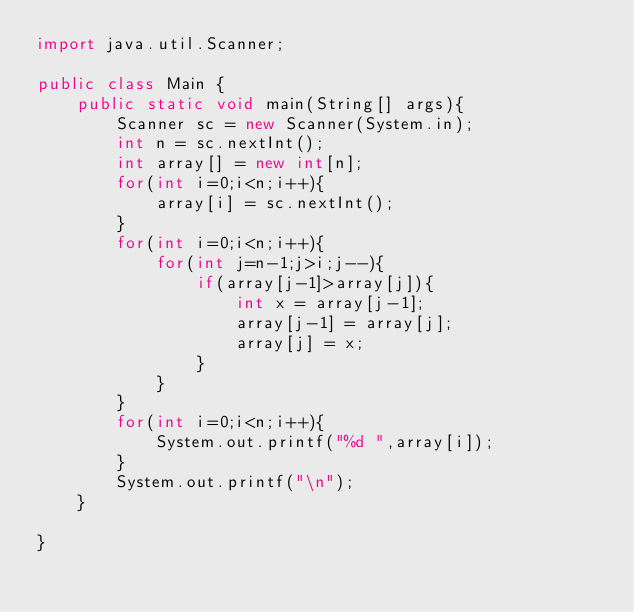Convert code to text. <code><loc_0><loc_0><loc_500><loc_500><_Java_>import java.util.Scanner;

public class Main {
	public static void main(String[] args){
		Scanner sc = new Scanner(System.in);
		int n = sc.nextInt();
		int array[] = new int[n];
		for(int i=0;i<n;i++){
			array[i] = sc.nextInt();
		}
		for(int i=0;i<n;i++){
			for(int j=n-1;j>i;j--){
				if(array[j-1]>array[j]){
					int x = array[j-1];
					array[j-1] = array[j];
					array[j] = x;
				}
			}
		}
		for(int i=0;i<n;i++){
			System.out.printf("%d ",array[i]);
		}
		System.out.printf("\n");
	}

}</code> 